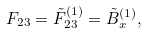Convert formula to latex. <formula><loc_0><loc_0><loc_500><loc_500>F _ { 2 3 } = \tilde { F } _ { 2 3 } ^ { ( 1 ) } = \tilde { B } _ { x } ^ { ( 1 ) } ,</formula> 